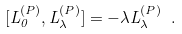Convert formula to latex. <formula><loc_0><loc_0><loc_500><loc_500>[ L _ { 0 } ^ { ( P ) } , L _ { \lambda } ^ { ( P ) } ] = - \lambda L _ { \lambda } ^ { ( P ) } \ .</formula> 